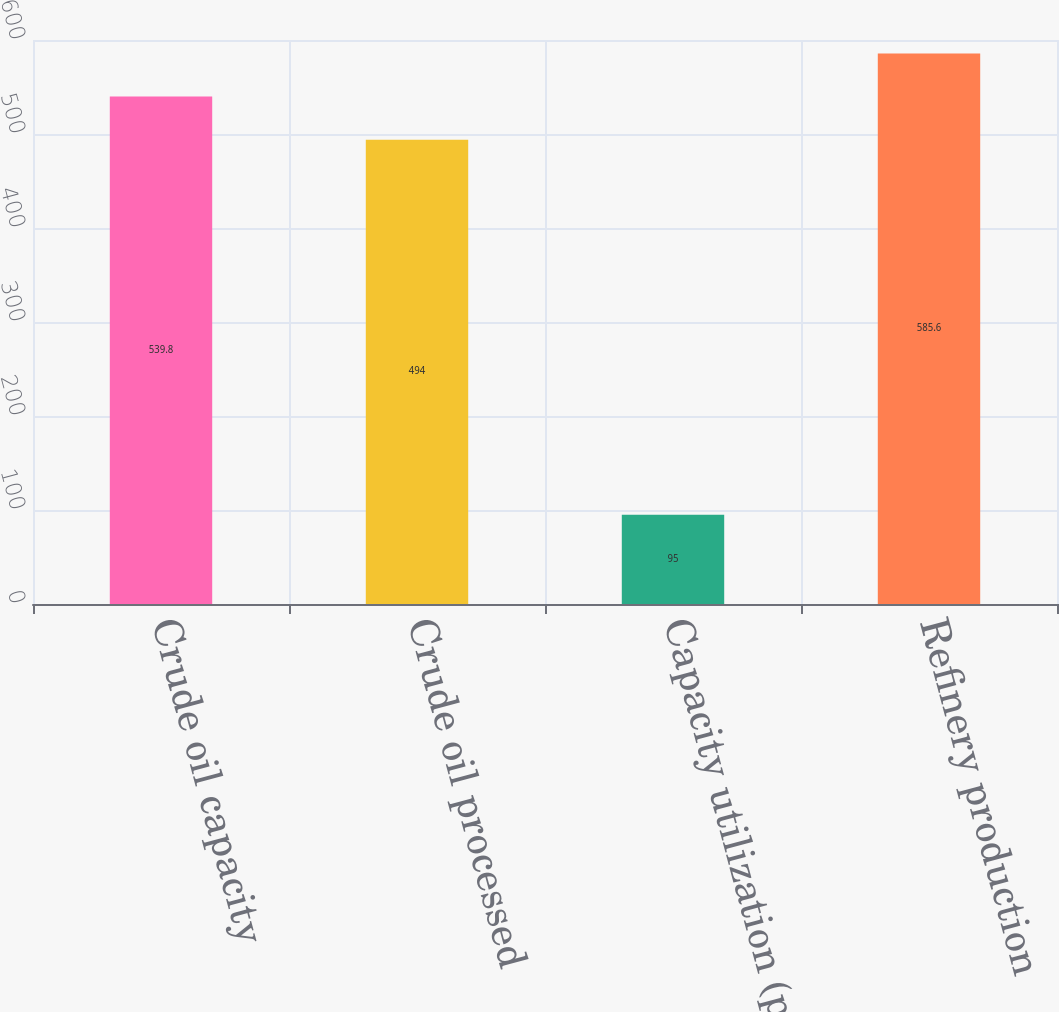Convert chart to OTSL. <chart><loc_0><loc_0><loc_500><loc_500><bar_chart><fcel>Crude oil capacity<fcel>Crude oil processed<fcel>Capacity utilization (percent)<fcel>Refinery production<nl><fcel>539.8<fcel>494<fcel>95<fcel>585.6<nl></chart> 